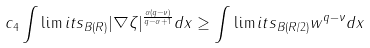Convert formula to latex. <formula><loc_0><loc_0><loc_500><loc_500>c _ { 4 } \int \lim i t s _ { B ( R ) } | \nabla \zeta | ^ { \frac { \alpha ( q - \nu ) } { q - \alpha + 1 } } d x \geq \int \lim i t s _ { B ( R / 2 ) } w ^ { q - \nu } d x</formula> 